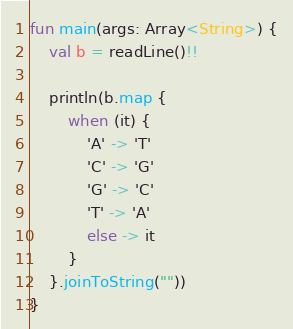<code> <loc_0><loc_0><loc_500><loc_500><_Kotlin_>fun main(args: Array<String>) {
    val b = readLine()!!

    println(b.map {
        when (it) {
            'A' -> 'T'
            'C' -> 'G'
            'G' -> 'C'
            'T' -> 'A'
            else -> it
        }
    }.joinToString(""))
}</code> 